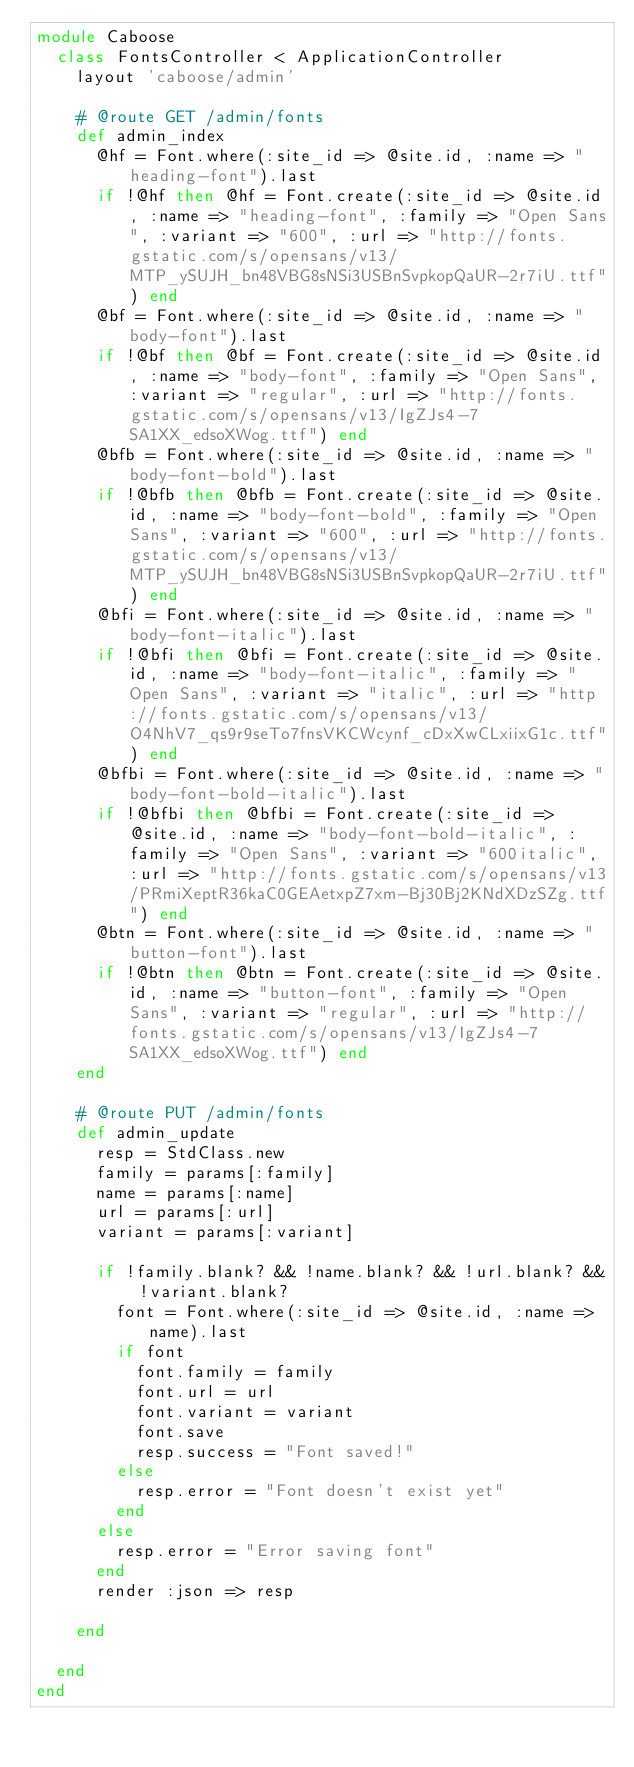Convert code to text. <code><loc_0><loc_0><loc_500><loc_500><_Ruby_>module Caboose
  class FontsController < ApplicationController
    layout 'caboose/admin'
    
    # @route GET /admin/fonts
    def admin_index
      @hf = Font.where(:site_id => @site.id, :name => "heading-font").last
      if !@hf then @hf = Font.create(:site_id => @site.id, :name => "heading-font", :family => "Open Sans", :variant => "600", :url => "http://fonts.gstatic.com/s/opensans/v13/MTP_ySUJH_bn48VBG8sNSi3USBnSvpkopQaUR-2r7iU.ttf") end
      @bf = Font.where(:site_id => @site.id, :name => "body-font").last
      if !@bf then @bf = Font.create(:site_id => @site.id, :name => "body-font", :family => "Open Sans", :variant => "regular", :url => "http://fonts.gstatic.com/s/opensans/v13/IgZJs4-7SA1XX_edsoXWog.ttf") end
      @bfb = Font.where(:site_id => @site.id, :name => "body-font-bold").last
      if !@bfb then @bfb = Font.create(:site_id => @site.id, :name => "body-font-bold", :family => "Open Sans", :variant => "600", :url => "http://fonts.gstatic.com/s/opensans/v13/MTP_ySUJH_bn48VBG8sNSi3USBnSvpkopQaUR-2r7iU.ttf") end
      @bfi = Font.where(:site_id => @site.id, :name => "body-font-italic").last
      if !@bfi then @bfi = Font.create(:site_id => @site.id, :name => "body-font-italic", :family => "Open Sans", :variant => "italic", :url => "http://fonts.gstatic.com/s/opensans/v13/O4NhV7_qs9r9seTo7fnsVKCWcynf_cDxXwCLxiixG1c.ttf") end
      @bfbi = Font.where(:site_id => @site.id, :name => "body-font-bold-italic").last
      if !@bfbi then @bfbi = Font.create(:site_id => @site.id, :name => "body-font-bold-italic", :family => "Open Sans", :variant => "600italic", :url => "http://fonts.gstatic.com/s/opensans/v13/PRmiXeptR36kaC0GEAetxpZ7xm-Bj30Bj2KNdXDzSZg.ttf") end
      @btn = Font.where(:site_id => @site.id, :name => "button-font").last
      if !@btn then @btn = Font.create(:site_id => @site.id, :name => "button-font", :family => "Open Sans", :variant => "regular", :url => "http://fonts.gstatic.com/s/opensans/v13/IgZJs4-7SA1XX_edsoXWog.ttf") end
    end

    # @route PUT /admin/fonts
    def admin_update
      resp = StdClass.new
      family = params[:family]
      name = params[:name]
      url = params[:url]
      variant = params[:variant]

      if !family.blank? && !name.blank? && !url.blank? && !variant.blank?
        font = Font.where(:site_id => @site.id, :name => name).last
        if font
          font.family = family
          font.url = url
          font.variant = variant
          font.save
          resp.success = "Font saved!"
        else
          resp.error = "Font doesn't exist yet"
        end
      else
        resp.error = "Error saving font"
      end
      render :json => resp

    end
            
  end
end</code> 